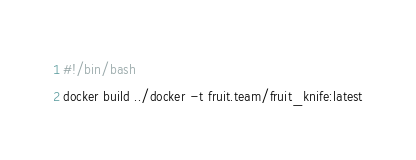<code> <loc_0><loc_0><loc_500><loc_500><_Bash_>#!/bin/bash
docker build ../docker -t fruit.team/fruit_knife:latest
</code> 